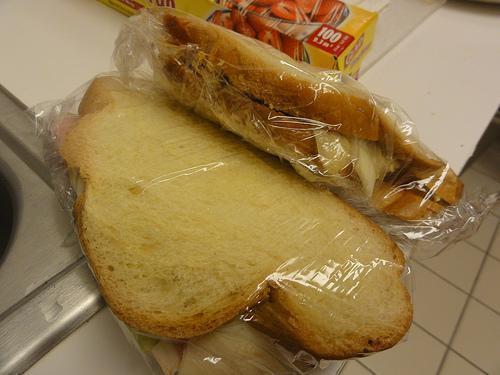How many sandwiches are there?
Give a very brief answer. 2. 